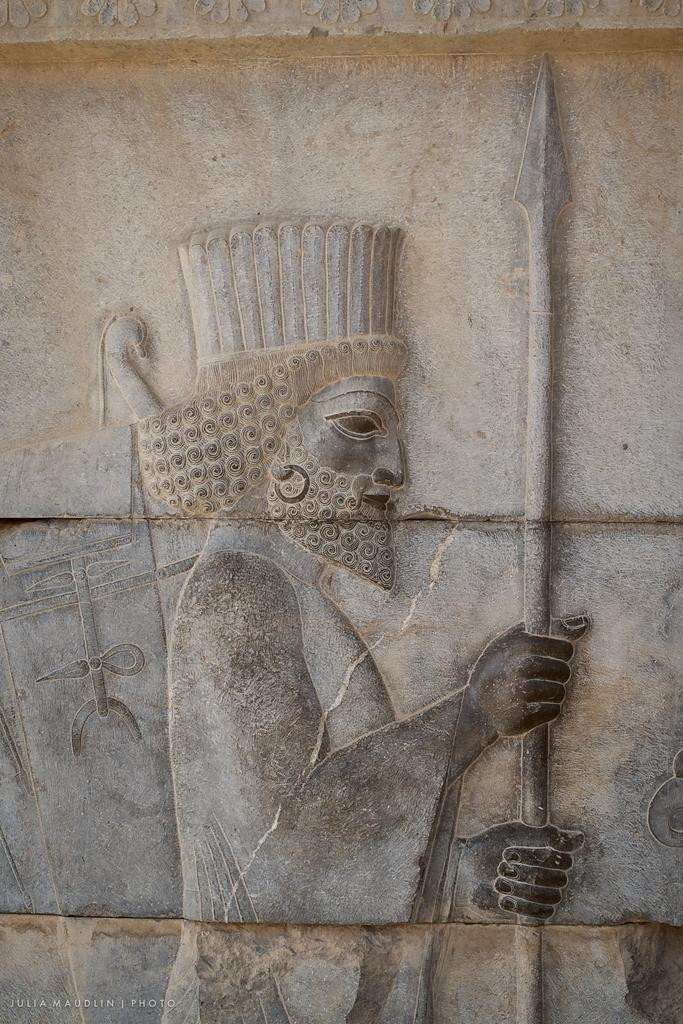What is present on the wall in the image? There is a sculpture on the wall in the image. Can you describe the sculpture? Unfortunately, the facts provided do not give a detailed description of the sculpture. What else can be seen in the image? There is writing in the left corner of the image. What type of thread is used to create the cherry depicted in the sculpture? There is no cherry depicted in the sculpture, as the facts provided do not mention any fruits or specific materials used in the sculpture. 